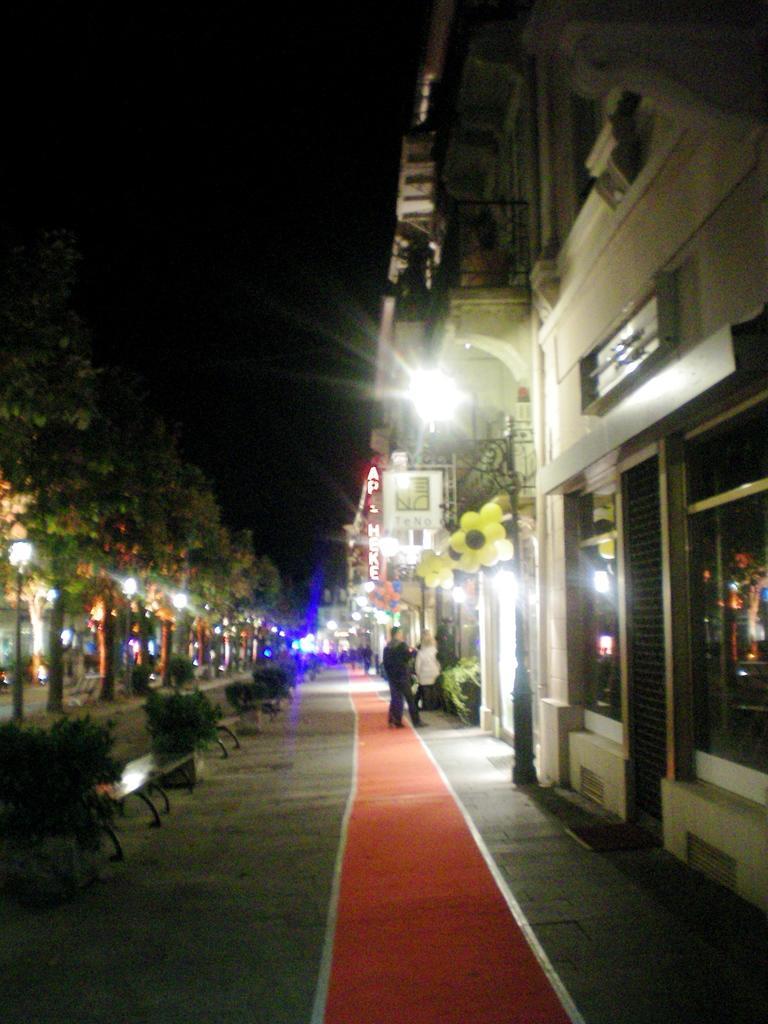How would you summarize this image in a sentence or two? In this image, I can see two persons standing on the pathway. On the left side of the image, there are trees, light poles, branches and bushes. On the right side of the image, I can see the buildings, name boards and balloons. The background is dark. 